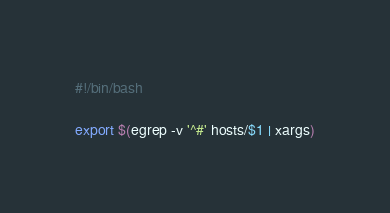Convert code to text. <code><loc_0><loc_0><loc_500><loc_500><_Bash_>#!/bin/bash

export $(egrep -v '^#' hosts/$1 | xargs)</code> 